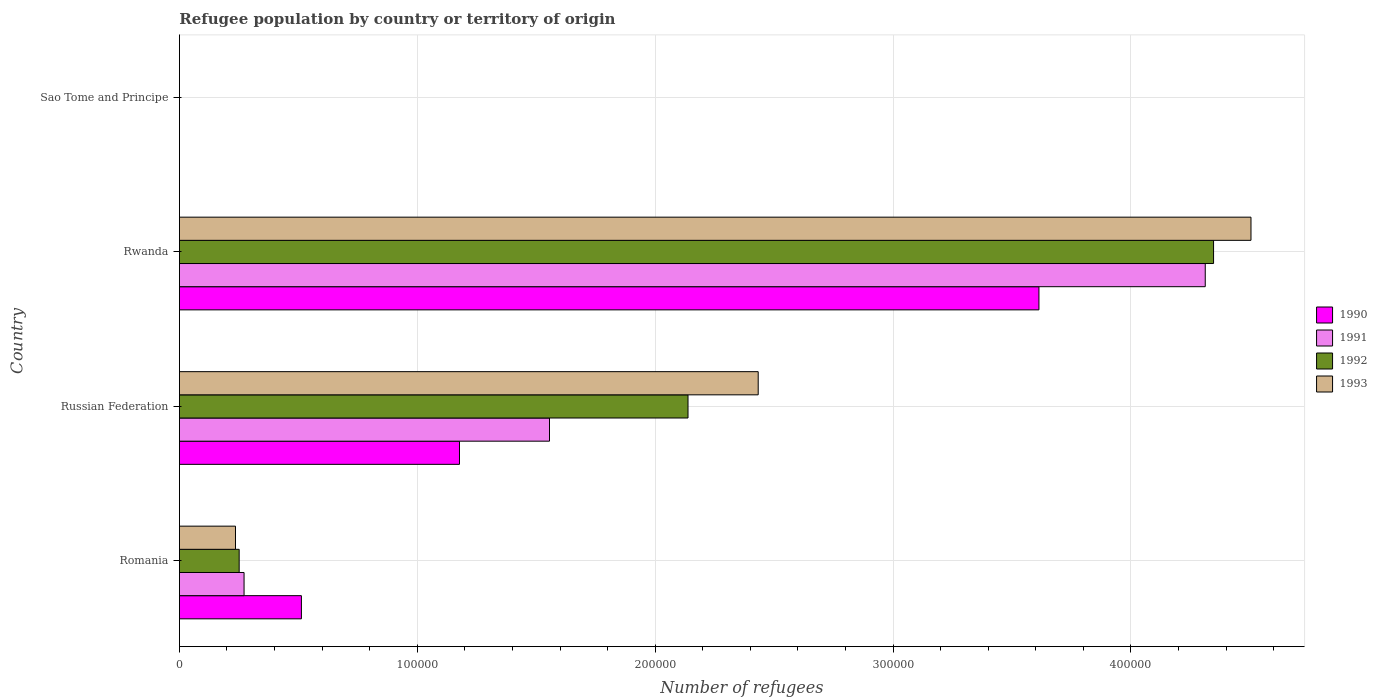How many different coloured bars are there?
Give a very brief answer. 4. How many groups of bars are there?
Ensure brevity in your answer.  4. How many bars are there on the 4th tick from the top?
Your response must be concise. 4. How many bars are there on the 2nd tick from the bottom?
Your answer should be compact. 4. What is the label of the 2nd group of bars from the top?
Make the answer very short. Rwanda. In how many cases, is the number of bars for a given country not equal to the number of legend labels?
Make the answer very short. 0. What is the number of refugees in 1990 in Russian Federation?
Your answer should be very brief. 1.18e+05. Across all countries, what is the maximum number of refugees in 1990?
Offer a terse response. 3.61e+05. Across all countries, what is the minimum number of refugees in 1990?
Your answer should be very brief. 1. In which country was the number of refugees in 1990 maximum?
Keep it short and to the point. Rwanda. In which country was the number of refugees in 1992 minimum?
Make the answer very short. Sao Tome and Principe. What is the total number of refugees in 1990 in the graph?
Provide a succinct answer. 5.30e+05. What is the difference between the number of refugees in 1991 in Romania and that in Sao Tome and Principe?
Offer a very short reply. 2.72e+04. What is the difference between the number of refugees in 1993 in Russian Federation and the number of refugees in 1990 in Romania?
Provide a short and direct response. 1.92e+05. What is the average number of refugees in 1990 per country?
Provide a succinct answer. 1.33e+05. What is the difference between the number of refugees in 1992 and number of refugees in 1993 in Sao Tome and Principe?
Your response must be concise. 0. What is the ratio of the number of refugees in 1991 in Rwanda to that in Sao Tome and Principe?
Provide a short and direct response. 4.31e+05. Is the number of refugees in 1990 in Russian Federation less than that in Rwanda?
Give a very brief answer. Yes. What is the difference between the highest and the second highest number of refugees in 1990?
Provide a short and direct response. 2.44e+05. What is the difference between the highest and the lowest number of refugees in 1991?
Provide a succinct answer. 4.31e+05. Is the sum of the number of refugees in 1992 in Russian Federation and Sao Tome and Principe greater than the maximum number of refugees in 1991 across all countries?
Your answer should be very brief. No. Is it the case that in every country, the sum of the number of refugees in 1992 and number of refugees in 1990 is greater than the sum of number of refugees in 1993 and number of refugees in 1991?
Your answer should be compact. No. What does the 3rd bar from the top in Rwanda represents?
Give a very brief answer. 1991. How many bars are there?
Your answer should be compact. 16. What is the difference between two consecutive major ticks on the X-axis?
Your answer should be compact. 1.00e+05. Are the values on the major ticks of X-axis written in scientific E-notation?
Offer a very short reply. No. Where does the legend appear in the graph?
Offer a very short reply. Center right. What is the title of the graph?
Give a very brief answer. Refugee population by country or territory of origin. Does "1962" appear as one of the legend labels in the graph?
Your answer should be compact. No. What is the label or title of the X-axis?
Offer a terse response. Number of refugees. What is the Number of refugees in 1990 in Romania?
Provide a succinct answer. 5.13e+04. What is the Number of refugees of 1991 in Romania?
Make the answer very short. 2.72e+04. What is the Number of refugees in 1992 in Romania?
Keep it short and to the point. 2.51e+04. What is the Number of refugees of 1993 in Romania?
Your response must be concise. 2.36e+04. What is the Number of refugees of 1990 in Russian Federation?
Make the answer very short. 1.18e+05. What is the Number of refugees in 1991 in Russian Federation?
Offer a very short reply. 1.56e+05. What is the Number of refugees of 1992 in Russian Federation?
Your response must be concise. 2.14e+05. What is the Number of refugees of 1993 in Russian Federation?
Keep it short and to the point. 2.43e+05. What is the Number of refugees of 1990 in Rwanda?
Offer a very short reply. 3.61e+05. What is the Number of refugees of 1991 in Rwanda?
Provide a short and direct response. 4.31e+05. What is the Number of refugees of 1992 in Rwanda?
Provide a succinct answer. 4.35e+05. What is the Number of refugees in 1993 in Rwanda?
Your answer should be compact. 4.50e+05. What is the Number of refugees of 1990 in Sao Tome and Principe?
Provide a short and direct response. 1. What is the Number of refugees in 1991 in Sao Tome and Principe?
Your answer should be very brief. 1. What is the Number of refugees in 1992 in Sao Tome and Principe?
Provide a short and direct response. 1. What is the Number of refugees in 1993 in Sao Tome and Principe?
Offer a very short reply. 1. Across all countries, what is the maximum Number of refugees in 1990?
Your answer should be compact. 3.61e+05. Across all countries, what is the maximum Number of refugees of 1991?
Make the answer very short. 4.31e+05. Across all countries, what is the maximum Number of refugees in 1992?
Provide a short and direct response. 4.35e+05. Across all countries, what is the maximum Number of refugees of 1993?
Ensure brevity in your answer.  4.50e+05. Across all countries, what is the minimum Number of refugees of 1990?
Offer a very short reply. 1. Across all countries, what is the minimum Number of refugees in 1991?
Your response must be concise. 1. What is the total Number of refugees in 1990 in the graph?
Offer a very short reply. 5.30e+05. What is the total Number of refugees of 1991 in the graph?
Provide a short and direct response. 6.14e+05. What is the total Number of refugees in 1992 in the graph?
Your response must be concise. 6.74e+05. What is the total Number of refugees in 1993 in the graph?
Ensure brevity in your answer.  7.17e+05. What is the difference between the Number of refugees of 1990 in Romania and that in Russian Federation?
Your response must be concise. -6.65e+04. What is the difference between the Number of refugees of 1991 in Romania and that in Russian Federation?
Your answer should be very brief. -1.28e+05. What is the difference between the Number of refugees in 1992 in Romania and that in Russian Federation?
Provide a succinct answer. -1.89e+05. What is the difference between the Number of refugees in 1993 in Romania and that in Russian Federation?
Ensure brevity in your answer.  -2.20e+05. What is the difference between the Number of refugees in 1990 in Romania and that in Rwanda?
Your response must be concise. -3.10e+05. What is the difference between the Number of refugees in 1991 in Romania and that in Rwanda?
Make the answer very short. -4.04e+05. What is the difference between the Number of refugees in 1992 in Romania and that in Rwanda?
Offer a very short reply. -4.10e+05. What is the difference between the Number of refugees in 1993 in Romania and that in Rwanda?
Your answer should be very brief. -4.27e+05. What is the difference between the Number of refugees in 1990 in Romania and that in Sao Tome and Principe?
Your answer should be compact. 5.13e+04. What is the difference between the Number of refugees of 1991 in Romania and that in Sao Tome and Principe?
Make the answer very short. 2.72e+04. What is the difference between the Number of refugees of 1992 in Romania and that in Sao Tome and Principe?
Provide a succinct answer. 2.51e+04. What is the difference between the Number of refugees of 1993 in Romania and that in Sao Tome and Principe?
Your response must be concise. 2.36e+04. What is the difference between the Number of refugees of 1990 in Russian Federation and that in Rwanda?
Ensure brevity in your answer.  -2.44e+05. What is the difference between the Number of refugees of 1991 in Russian Federation and that in Rwanda?
Your response must be concise. -2.76e+05. What is the difference between the Number of refugees in 1992 in Russian Federation and that in Rwanda?
Make the answer very short. -2.21e+05. What is the difference between the Number of refugees of 1993 in Russian Federation and that in Rwanda?
Keep it short and to the point. -2.07e+05. What is the difference between the Number of refugees of 1990 in Russian Federation and that in Sao Tome and Principe?
Your answer should be compact. 1.18e+05. What is the difference between the Number of refugees of 1991 in Russian Federation and that in Sao Tome and Principe?
Give a very brief answer. 1.56e+05. What is the difference between the Number of refugees in 1992 in Russian Federation and that in Sao Tome and Principe?
Provide a short and direct response. 2.14e+05. What is the difference between the Number of refugees in 1993 in Russian Federation and that in Sao Tome and Principe?
Provide a short and direct response. 2.43e+05. What is the difference between the Number of refugees in 1990 in Rwanda and that in Sao Tome and Principe?
Make the answer very short. 3.61e+05. What is the difference between the Number of refugees in 1991 in Rwanda and that in Sao Tome and Principe?
Your answer should be very brief. 4.31e+05. What is the difference between the Number of refugees of 1992 in Rwanda and that in Sao Tome and Principe?
Provide a succinct answer. 4.35e+05. What is the difference between the Number of refugees of 1993 in Rwanda and that in Sao Tome and Principe?
Offer a very short reply. 4.50e+05. What is the difference between the Number of refugees in 1990 in Romania and the Number of refugees in 1991 in Russian Federation?
Provide a succinct answer. -1.04e+05. What is the difference between the Number of refugees in 1990 in Romania and the Number of refugees in 1992 in Russian Federation?
Provide a short and direct response. -1.63e+05. What is the difference between the Number of refugees in 1990 in Romania and the Number of refugees in 1993 in Russian Federation?
Keep it short and to the point. -1.92e+05. What is the difference between the Number of refugees in 1991 in Romania and the Number of refugees in 1992 in Russian Federation?
Your answer should be very brief. -1.87e+05. What is the difference between the Number of refugees in 1991 in Romania and the Number of refugees in 1993 in Russian Federation?
Provide a short and direct response. -2.16e+05. What is the difference between the Number of refugees in 1992 in Romania and the Number of refugees in 1993 in Russian Federation?
Ensure brevity in your answer.  -2.18e+05. What is the difference between the Number of refugees in 1990 in Romania and the Number of refugees in 1991 in Rwanda?
Your answer should be compact. -3.80e+05. What is the difference between the Number of refugees of 1990 in Romania and the Number of refugees of 1992 in Rwanda?
Offer a terse response. -3.83e+05. What is the difference between the Number of refugees of 1990 in Romania and the Number of refugees of 1993 in Rwanda?
Your answer should be compact. -3.99e+05. What is the difference between the Number of refugees of 1991 in Romania and the Number of refugees of 1992 in Rwanda?
Your answer should be very brief. -4.08e+05. What is the difference between the Number of refugees in 1991 in Romania and the Number of refugees in 1993 in Rwanda?
Give a very brief answer. -4.23e+05. What is the difference between the Number of refugees of 1992 in Romania and the Number of refugees of 1993 in Rwanda?
Ensure brevity in your answer.  -4.25e+05. What is the difference between the Number of refugees in 1990 in Romania and the Number of refugees in 1991 in Sao Tome and Principe?
Your answer should be compact. 5.13e+04. What is the difference between the Number of refugees in 1990 in Romania and the Number of refugees in 1992 in Sao Tome and Principe?
Give a very brief answer. 5.13e+04. What is the difference between the Number of refugees in 1990 in Romania and the Number of refugees in 1993 in Sao Tome and Principe?
Offer a very short reply. 5.13e+04. What is the difference between the Number of refugees in 1991 in Romania and the Number of refugees in 1992 in Sao Tome and Principe?
Your answer should be compact. 2.72e+04. What is the difference between the Number of refugees of 1991 in Romania and the Number of refugees of 1993 in Sao Tome and Principe?
Give a very brief answer. 2.72e+04. What is the difference between the Number of refugees of 1992 in Romania and the Number of refugees of 1993 in Sao Tome and Principe?
Make the answer very short. 2.51e+04. What is the difference between the Number of refugees of 1990 in Russian Federation and the Number of refugees of 1991 in Rwanda?
Provide a succinct answer. -3.14e+05. What is the difference between the Number of refugees of 1990 in Russian Federation and the Number of refugees of 1992 in Rwanda?
Your response must be concise. -3.17e+05. What is the difference between the Number of refugees of 1990 in Russian Federation and the Number of refugees of 1993 in Rwanda?
Offer a very short reply. -3.33e+05. What is the difference between the Number of refugees of 1991 in Russian Federation and the Number of refugees of 1992 in Rwanda?
Your answer should be very brief. -2.79e+05. What is the difference between the Number of refugees in 1991 in Russian Federation and the Number of refugees in 1993 in Rwanda?
Your response must be concise. -2.95e+05. What is the difference between the Number of refugees in 1992 in Russian Federation and the Number of refugees in 1993 in Rwanda?
Keep it short and to the point. -2.37e+05. What is the difference between the Number of refugees of 1990 in Russian Federation and the Number of refugees of 1991 in Sao Tome and Principe?
Provide a succinct answer. 1.18e+05. What is the difference between the Number of refugees in 1990 in Russian Federation and the Number of refugees in 1992 in Sao Tome and Principe?
Give a very brief answer. 1.18e+05. What is the difference between the Number of refugees of 1990 in Russian Federation and the Number of refugees of 1993 in Sao Tome and Principe?
Your answer should be compact. 1.18e+05. What is the difference between the Number of refugees in 1991 in Russian Federation and the Number of refugees in 1992 in Sao Tome and Principe?
Your answer should be very brief. 1.56e+05. What is the difference between the Number of refugees in 1991 in Russian Federation and the Number of refugees in 1993 in Sao Tome and Principe?
Give a very brief answer. 1.56e+05. What is the difference between the Number of refugees of 1992 in Russian Federation and the Number of refugees of 1993 in Sao Tome and Principe?
Keep it short and to the point. 2.14e+05. What is the difference between the Number of refugees in 1990 in Rwanda and the Number of refugees in 1991 in Sao Tome and Principe?
Offer a very short reply. 3.61e+05. What is the difference between the Number of refugees of 1990 in Rwanda and the Number of refugees of 1992 in Sao Tome and Principe?
Offer a terse response. 3.61e+05. What is the difference between the Number of refugees in 1990 in Rwanda and the Number of refugees in 1993 in Sao Tome and Principe?
Make the answer very short. 3.61e+05. What is the difference between the Number of refugees in 1991 in Rwanda and the Number of refugees in 1992 in Sao Tome and Principe?
Give a very brief answer. 4.31e+05. What is the difference between the Number of refugees of 1991 in Rwanda and the Number of refugees of 1993 in Sao Tome and Principe?
Keep it short and to the point. 4.31e+05. What is the difference between the Number of refugees in 1992 in Rwanda and the Number of refugees in 1993 in Sao Tome and Principe?
Your answer should be very brief. 4.35e+05. What is the average Number of refugees in 1990 per country?
Your answer should be compact. 1.33e+05. What is the average Number of refugees in 1991 per country?
Give a very brief answer. 1.53e+05. What is the average Number of refugees of 1992 per country?
Provide a short and direct response. 1.68e+05. What is the average Number of refugees in 1993 per country?
Offer a very short reply. 1.79e+05. What is the difference between the Number of refugees in 1990 and Number of refugees in 1991 in Romania?
Ensure brevity in your answer.  2.41e+04. What is the difference between the Number of refugees of 1990 and Number of refugees of 1992 in Romania?
Offer a very short reply. 2.62e+04. What is the difference between the Number of refugees of 1990 and Number of refugees of 1993 in Romania?
Provide a succinct answer. 2.77e+04. What is the difference between the Number of refugees of 1991 and Number of refugees of 1992 in Romania?
Make the answer very short. 2059. What is the difference between the Number of refugees in 1991 and Number of refugees in 1993 in Romania?
Keep it short and to the point. 3605. What is the difference between the Number of refugees in 1992 and Number of refugees in 1993 in Romania?
Provide a short and direct response. 1546. What is the difference between the Number of refugees in 1990 and Number of refugees in 1991 in Russian Federation?
Your response must be concise. -3.78e+04. What is the difference between the Number of refugees in 1990 and Number of refugees in 1992 in Russian Federation?
Give a very brief answer. -9.61e+04. What is the difference between the Number of refugees of 1990 and Number of refugees of 1993 in Russian Federation?
Provide a short and direct response. -1.26e+05. What is the difference between the Number of refugees of 1991 and Number of refugees of 1992 in Russian Federation?
Make the answer very short. -5.82e+04. What is the difference between the Number of refugees of 1991 and Number of refugees of 1993 in Russian Federation?
Provide a short and direct response. -8.77e+04. What is the difference between the Number of refugees of 1992 and Number of refugees of 1993 in Russian Federation?
Provide a short and direct response. -2.95e+04. What is the difference between the Number of refugees of 1990 and Number of refugees of 1991 in Rwanda?
Offer a terse response. -6.99e+04. What is the difference between the Number of refugees in 1990 and Number of refugees in 1992 in Rwanda?
Your answer should be very brief. -7.34e+04. What is the difference between the Number of refugees in 1990 and Number of refugees in 1993 in Rwanda?
Give a very brief answer. -8.91e+04. What is the difference between the Number of refugees of 1991 and Number of refugees of 1992 in Rwanda?
Offer a very short reply. -3496. What is the difference between the Number of refugees in 1991 and Number of refugees in 1993 in Rwanda?
Your response must be concise. -1.92e+04. What is the difference between the Number of refugees of 1992 and Number of refugees of 1993 in Rwanda?
Give a very brief answer. -1.57e+04. What is the difference between the Number of refugees of 1990 and Number of refugees of 1991 in Sao Tome and Principe?
Make the answer very short. 0. What is the difference between the Number of refugees in 1991 and Number of refugees in 1992 in Sao Tome and Principe?
Provide a succinct answer. 0. What is the difference between the Number of refugees in 1991 and Number of refugees in 1993 in Sao Tome and Principe?
Make the answer very short. 0. What is the ratio of the Number of refugees of 1990 in Romania to that in Russian Federation?
Your answer should be compact. 0.44. What is the ratio of the Number of refugees in 1991 in Romania to that in Russian Federation?
Give a very brief answer. 0.17. What is the ratio of the Number of refugees of 1992 in Romania to that in Russian Federation?
Offer a very short reply. 0.12. What is the ratio of the Number of refugees in 1993 in Romania to that in Russian Federation?
Your response must be concise. 0.1. What is the ratio of the Number of refugees in 1990 in Romania to that in Rwanda?
Make the answer very short. 0.14. What is the ratio of the Number of refugees in 1991 in Romania to that in Rwanda?
Offer a very short reply. 0.06. What is the ratio of the Number of refugees in 1992 in Romania to that in Rwanda?
Your answer should be very brief. 0.06. What is the ratio of the Number of refugees of 1993 in Romania to that in Rwanda?
Your answer should be compact. 0.05. What is the ratio of the Number of refugees of 1990 in Romania to that in Sao Tome and Principe?
Offer a terse response. 5.13e+04. What is the ratio of the Number of refugees in 1991 in Romania to that in Sao Tome and Principe?
Your response must be concise. 2.72e+04. What is the ratio of the Number of refugees of 1992 in Romania to that in Sao Tome and Principe?
Ensure brevity in your answer.  2.51e+04. What is the ratio of the Number of refugees of 1993 in Romania to that in Sao Tome and Principe?
Ensure brevity in your answer.  2.36e+04. What is the ratio of the Number of refugees in 1990 in Russian Federation to that in Rwanda?
Offer a terse response. 0.33. What is the ratio of the Number of refugees in 1991 in Russian Federation to that in Rwanda?
Your answer should be compact. 0.36. What is the ratio of the Number of refugees in 1992 in Russian Federation to that in Rwanda?
Offer a very short reply. 0.49. What is the ratio of the Number of refugees in 1993 in Russian Federation to that in Rwanda?
Offer a terse response. 0.54. What is the ratio of the Number of refugees of 1990 in Russian Federation to that in Sao Tome and Principe?
Offer a very short reply. 1.18e+05. What is the ratio of the Number of refugees of 1991 in Russian Federation to that in Sao Tome and Principe?
Your answer should be compact. 1.56e+05. What is the ratio of the Number of refugees in 1992 in Russian Federation to that in Sao Tome and Principe?
Provide a short and direct response. 2.14e+05. What is the ratio of the Number of refugees in 1993 in Russian Federation to that in Sao Tome and Principe?
Give a very brief answer. 2.43e+05. What is the ratio of the Number of refugees of 1990 in Rwanda to that in Sao Tome and Principe?
Your answer should be very brief. 3.61e+05. What is the ratio of the Number of refugees of 1991 in Rwanda to that in Sao Tome and Principe?
Your response must be concise. 4.31e+05. What is the ratio of the Number of refugees of 1992 in Rwanda to that in Sao Tome and Principe?
Offer a terse response. 4.35e+05. What is the ratio of the Number of refugees in 1993 in Rwanda to that in Sao Tome and Principe?
Make the answer very short. 4.50e+05. What is the difference between the highest and the second highest Number of refugees of 1990?
Offer a very short reply. 2.44e+05. What is the difference between the highest and the second highest Number of refugees of 1991?
Make the answer very short. 2.76e+05. What is the difference between the highest and the second highest Number of refugees in 1992?
Keep it short and to the point. 2.21e+05. What is the difference between the highest and the second highest Number of refugees in 1993?
Provide a short and direct response. 2.07e+05. What is the difference between the highest and the lowest Number of refugees of 1990?
Offer a very short reply. 3.61e+05. What is the difference between the highest and the lowest Number of refugees of 1991?
Make the answer very short. 4.31e+05. What is the difference between the highest and the lowest Number of refugees of 1992?
Your response must be concise. 4.35e+05. What is the difference between the highest and the lowest Number of refugees in 1993?
Offer a terse response. 4.50e+05. 